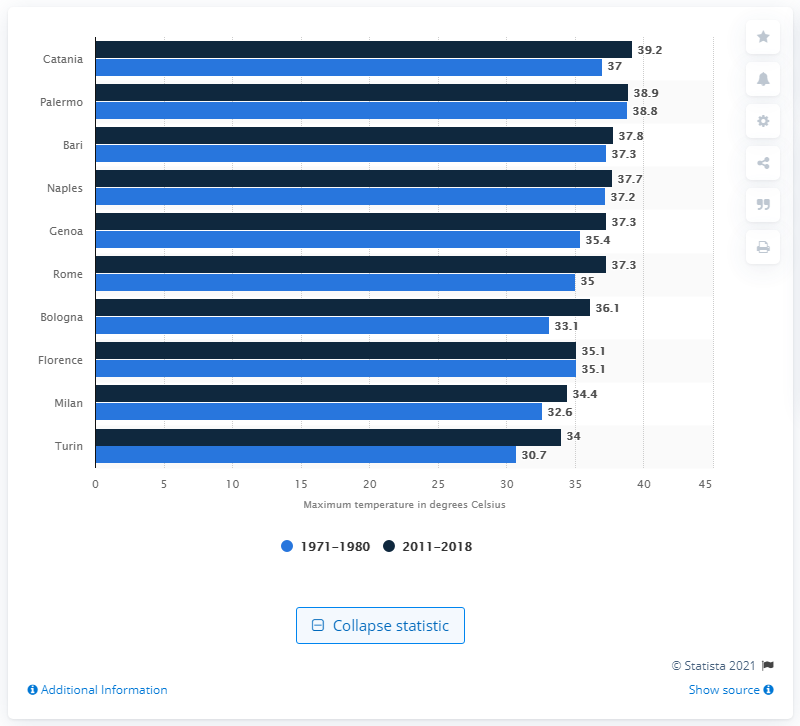List a handful of essential elements in this visual. Turin had the largest increase in temperature between 2011 and 2018 among all cities. 